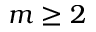Convert formula to latex. <formula><loc_0><loc_0><loc_500><loc_500>m \geq 2</formula> 